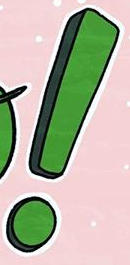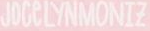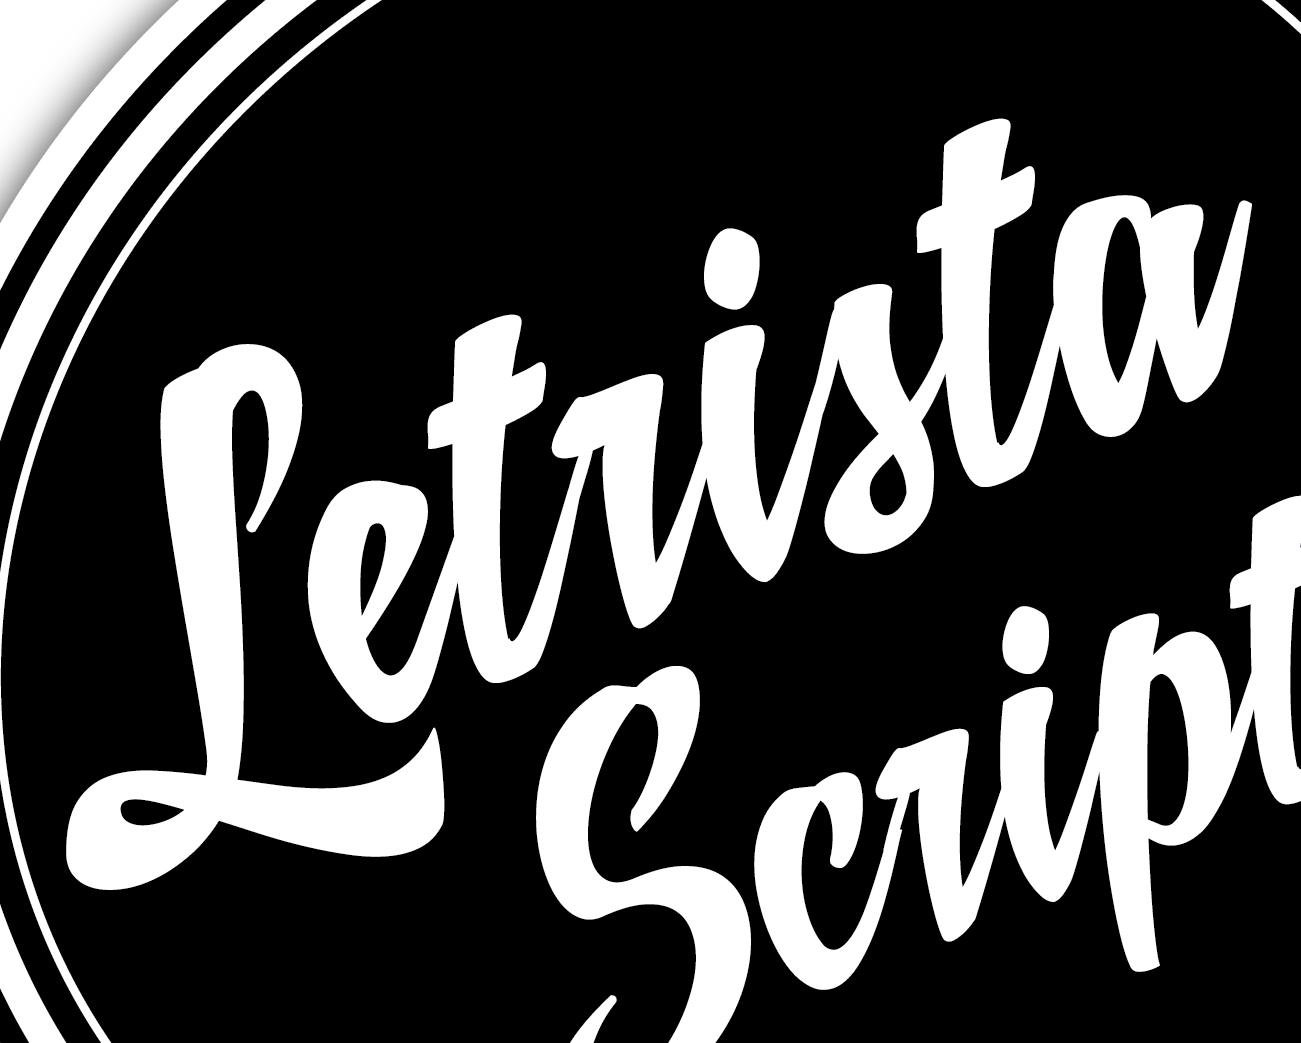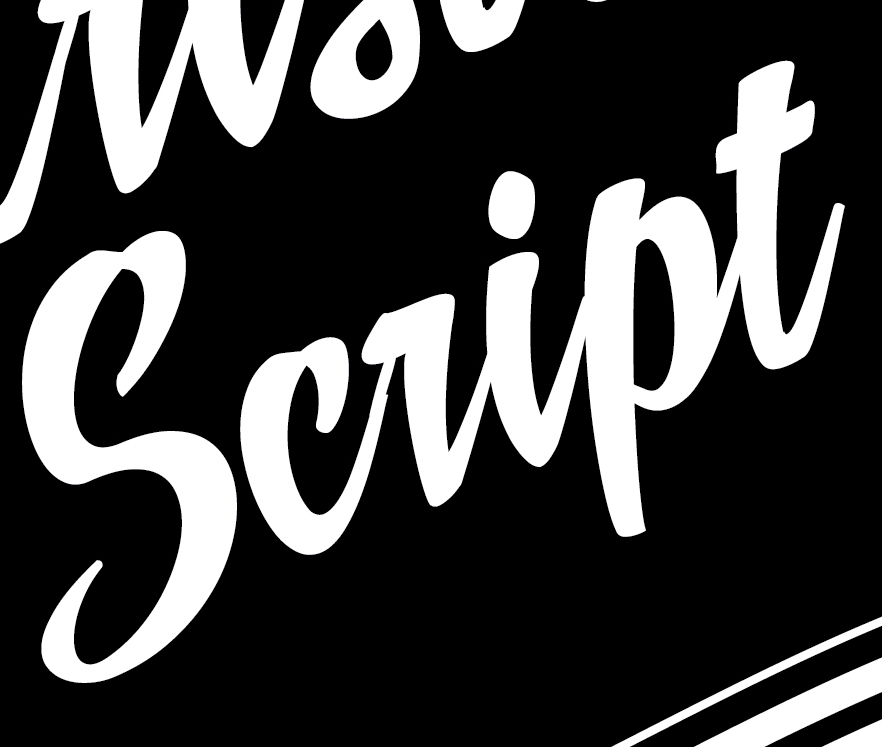Identify the words shown in these images in order, separated by a semicolon. !; JOCeLYNMONIZ; Letrista; script 